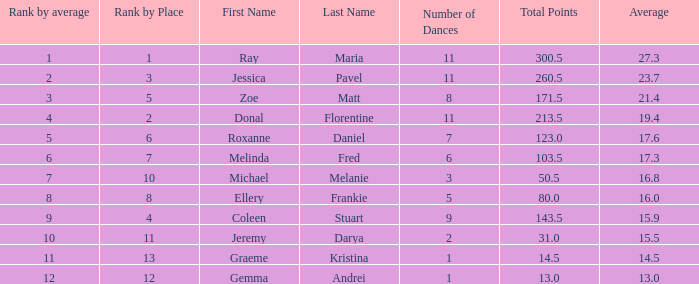What is the couples name where the average is 15.9? Coleen & Stuart. Would you be able to parse every entry in this table? {'header': ['Rank by average', 'Rank by Place', 'First Name', 'Last Name', 'Number of Dances', 'Total Points', 'Average'], 'rows': [['1', '1', 'Ray', 'Maria', '11', '300.5', '27.3'], ['2', '3', 'Jessica', 'Pavel', '11', '260.5', '23.7'], ['3', '5', 'Zoe', 'Matt', '8', '171.5', '21.4'], ['4', '2', 'Donal', 'Florentine', '11', '213.5', '19.4'], ['5', '6', 'Roxanne', 'Daniel', '7', '123.0', '17.6'], ['6', '7', 'Melinda', 'Fred', '6', '103.5', '17.3'], ['7', '10', 'Michael', 'Melanie', '3', '50.5', '16.8'], ['8', '8', 'Ellery', 'Frankie', '5', '80.0', '16.0'], ['9', '4', 'Coleen', 'Stuart', '9', '143.5', '15.9'], ['10', '11', 'Jeremy', 'Darya', '2', '31.0', '15.5'], ['11', '13', 'Graeme', 'Kristina', '1', '14.5', '14.5'], ['12', '12', 'Gemma', 'Andrei', '1', '13.0', '13.0']]} 